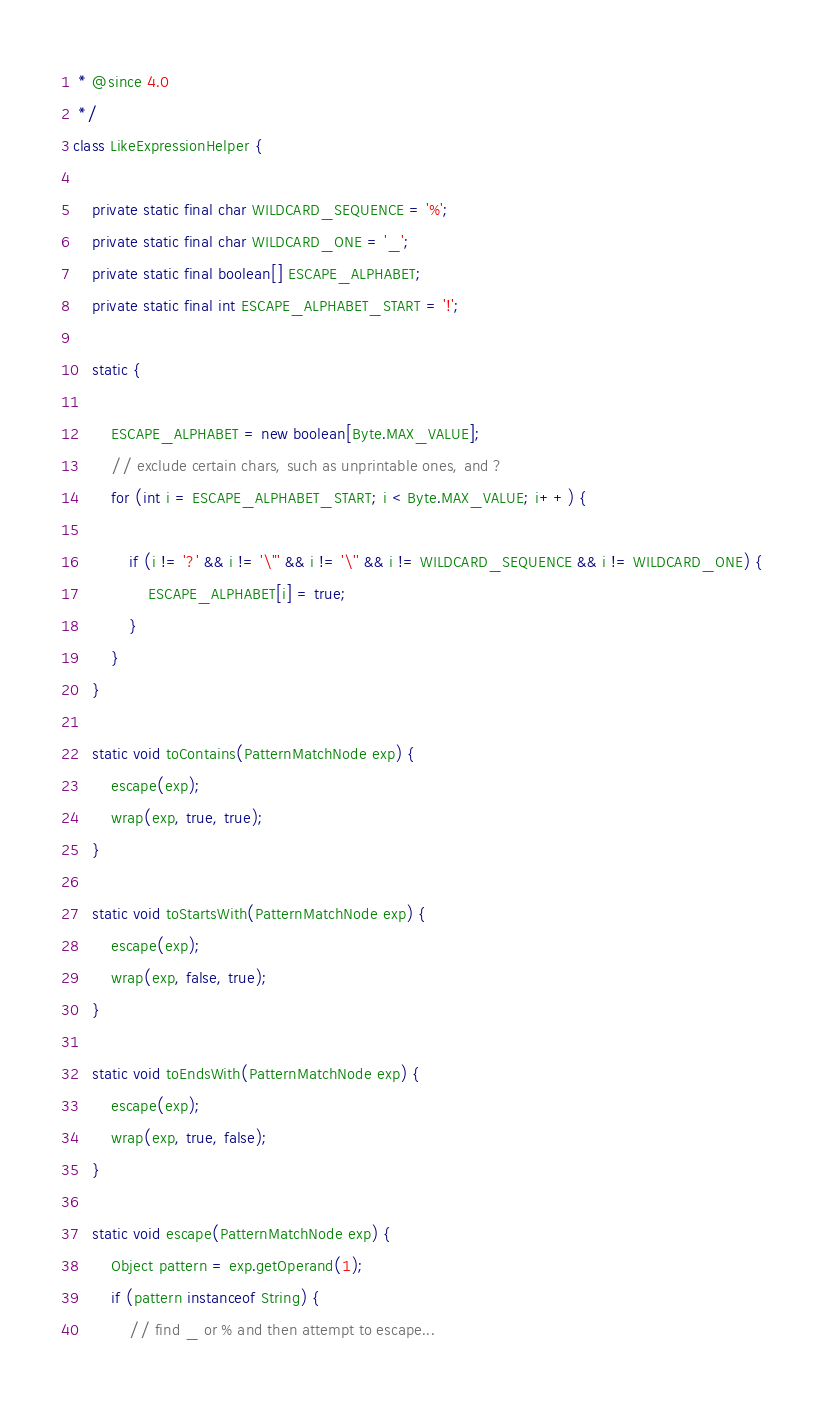<code> <loc_0><loc_0><loc_500><loc_500><_Java_> * @since 4.0
 */
class LikeExpressionHelper {

	private static final char WILDCARD_SEQUENCE = '%';
	private static final char WILDCARD_ONE = '_';
	private static final boolean[] ESCAPE_ALPHABET;
	private static final int ESCAPE_ALPHABET_START = '!';

	static {

		ESCAPE_ALPHABET = new boolean[Byte.MAX_VALUE];
		// exclude certain chars, such as unprintable ones, and ?
		for (int i = ESCAPE_ALPHABET_START; i < Byte.MAX_VALUE; i++) {

			if (i != '?' && i != '\"' && i != '\'' && i != WILDCARD_SEQUENCE && i != WILDCARD_ONE) {
				ESCAPE_ALPHABET[i] = true;
			}
		}
	}

	static void toContains(PatternMatchNode exp) {
		escape(exp);
		wrap(exp, true, true);
	}

	static void toStartsWith(PatternMatchNode exp) {
		escape(exp);
		wrap(exp, false, true);
	}

	static void toEndsWith(PatternMatchNode exp) {
		escape(exp);
		wrap(exp, true, false);
	}

	static void escape(PatternMatchNode exp) {
		Object pattern = exp.getOperand(1);
		if (pattern instanceof String) {
			// find _ or % and then attempt to escape...
</code> 